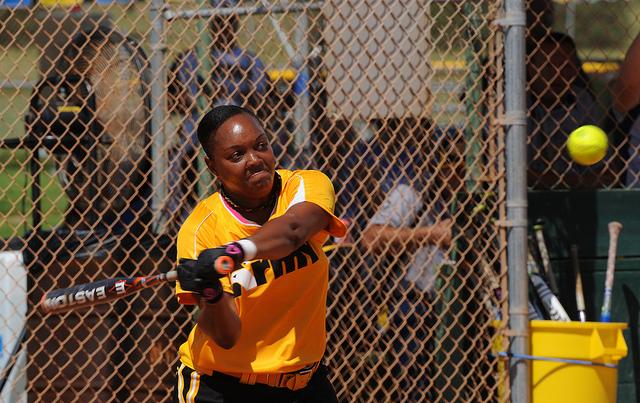What is the brand of bat being used?
Give a very brief answer. Easton. What material is the fence made of?
Keep it brief. Chain link. What sport is being played?
Quick response, please. Baseball. How many people are holding bats?
Keep it brief. 1. 